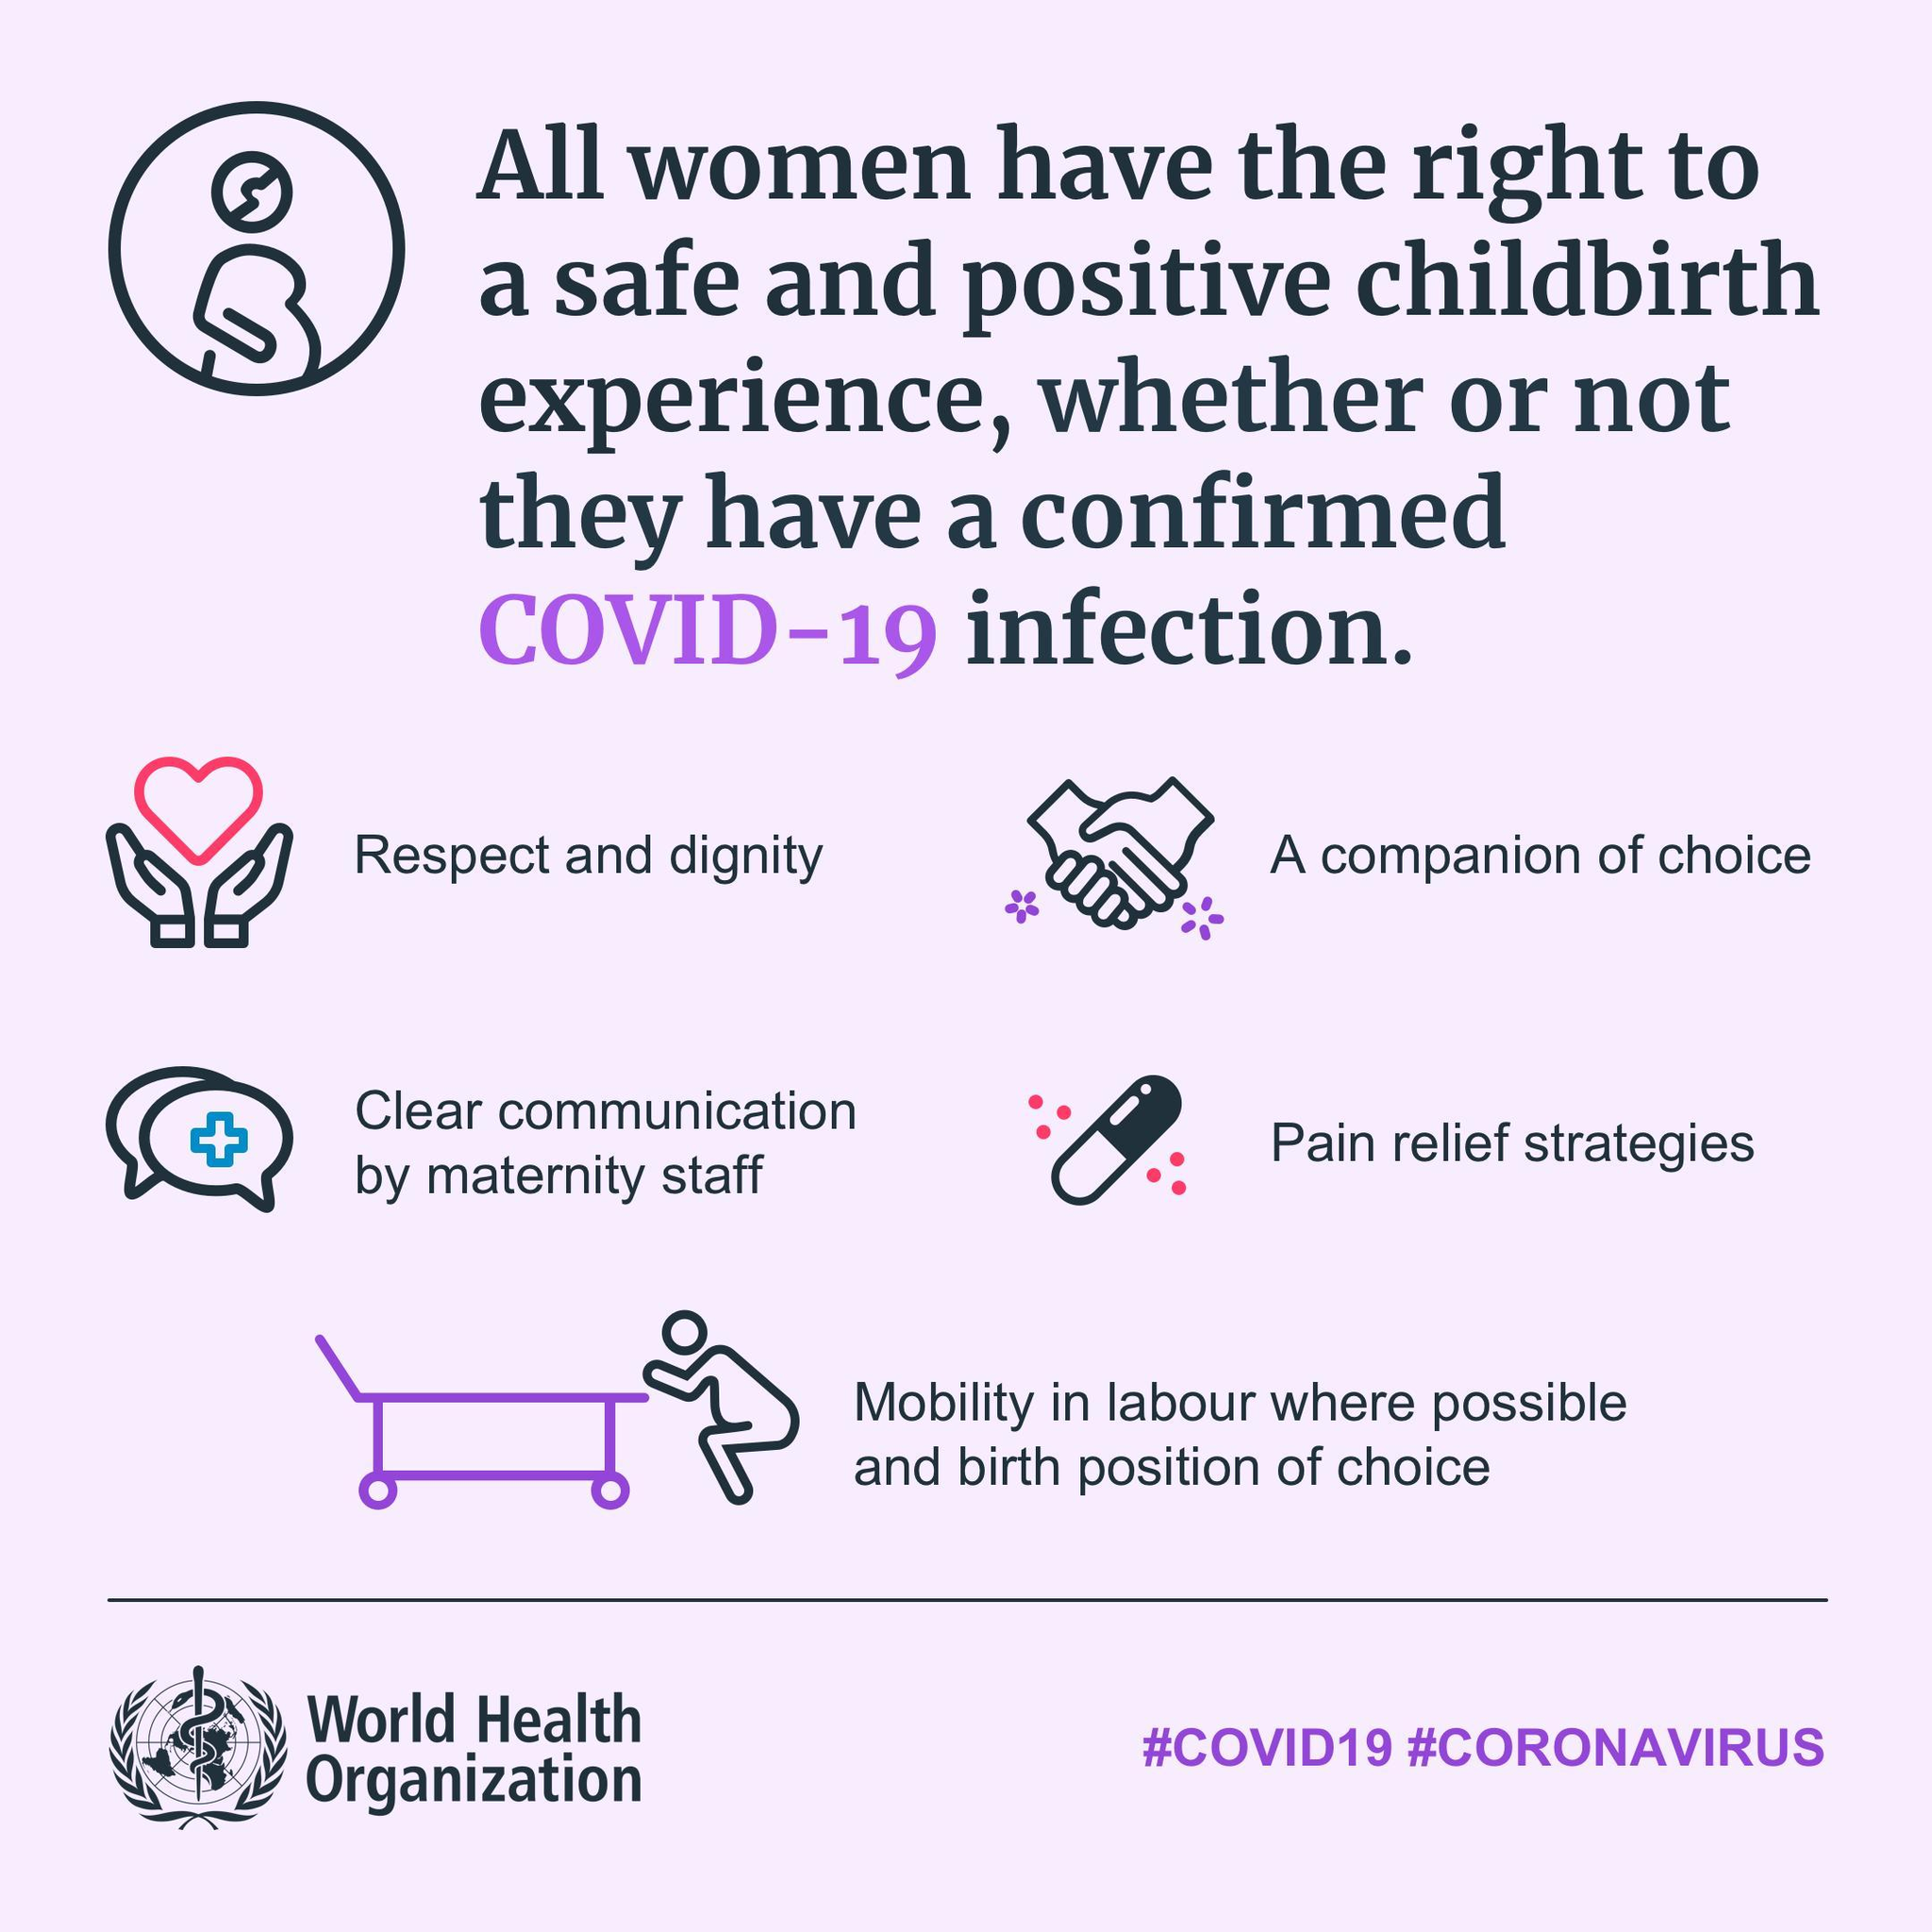How many requisites for a positive childbirth experience are mentioned here?
Answer the question with a short phrase. 5 Who is responsible for making clear communication? Maternity staff Which requisite is represented by the image of a capsule? Pain relief strategies Which requisite is represented by the image of a handshake? A companion of choice Which is the last requisite mentioned, to ensure a safe and positive childbirth experience? Mobility in labour where possible and birth position of choice Which requisite is represented by the image of a heart? Respect and dignity 